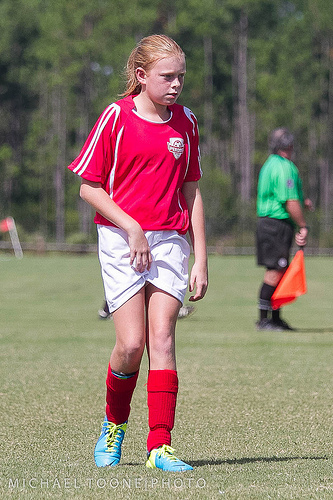<image>
Can you confirm if the flag is on the turf? No. The flag is not positioned on the turf. They may be near each other, but the flag is not supported by or resting on top of the turf. Is the flag next to the girl? No. The flag is not positioned next to the girl. They are located in different areas of the scene. 